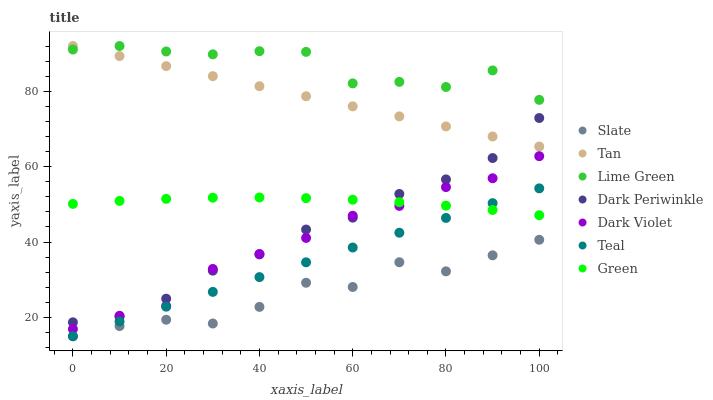Does Slate have the minimum area under the curve?
Answer yes or no. Yes. Does Lime Green have the maximum area under the curve?
Answer yes or no. Yes. Does Dark Violet have the minimum area under the curve?
Answer yes or no. No. Does Dark Violet have the maximum area under the curve?
Answer yes or no. No. Is Teal the smoothest?
Answer yes or no. Yes. Is Lime Green the roughest?
Answer yes or no. Yes. Is Dark Violet the smoothest?
Answer yes or no. No. Is Dark Violet the roughest?
Answer yes or no. No. Does Slate have the lowest value?
Answer yes or no. Yes. Does Dark Violet have the lowest value?
Answer yes or no. No. Does Lime Green have the highest value?
Answer yes or no. Yes. Does Dark Violet have the highest value?
Answer yes or no. No. Is Dark Violet less than Lime Green?
Answer yes or no. Yes. Is Dark Violet greater than Teal?
Answer yes or no. Yes. Does Green intersect Teal?
Answer yes or no. Yes. Is Green less than Teal?
Answer yes or no. No. Is Green greater than Teal?
Answer yes or no. No. Does Dark Violet intersect Lime Green?
Answer yes or no. No. 